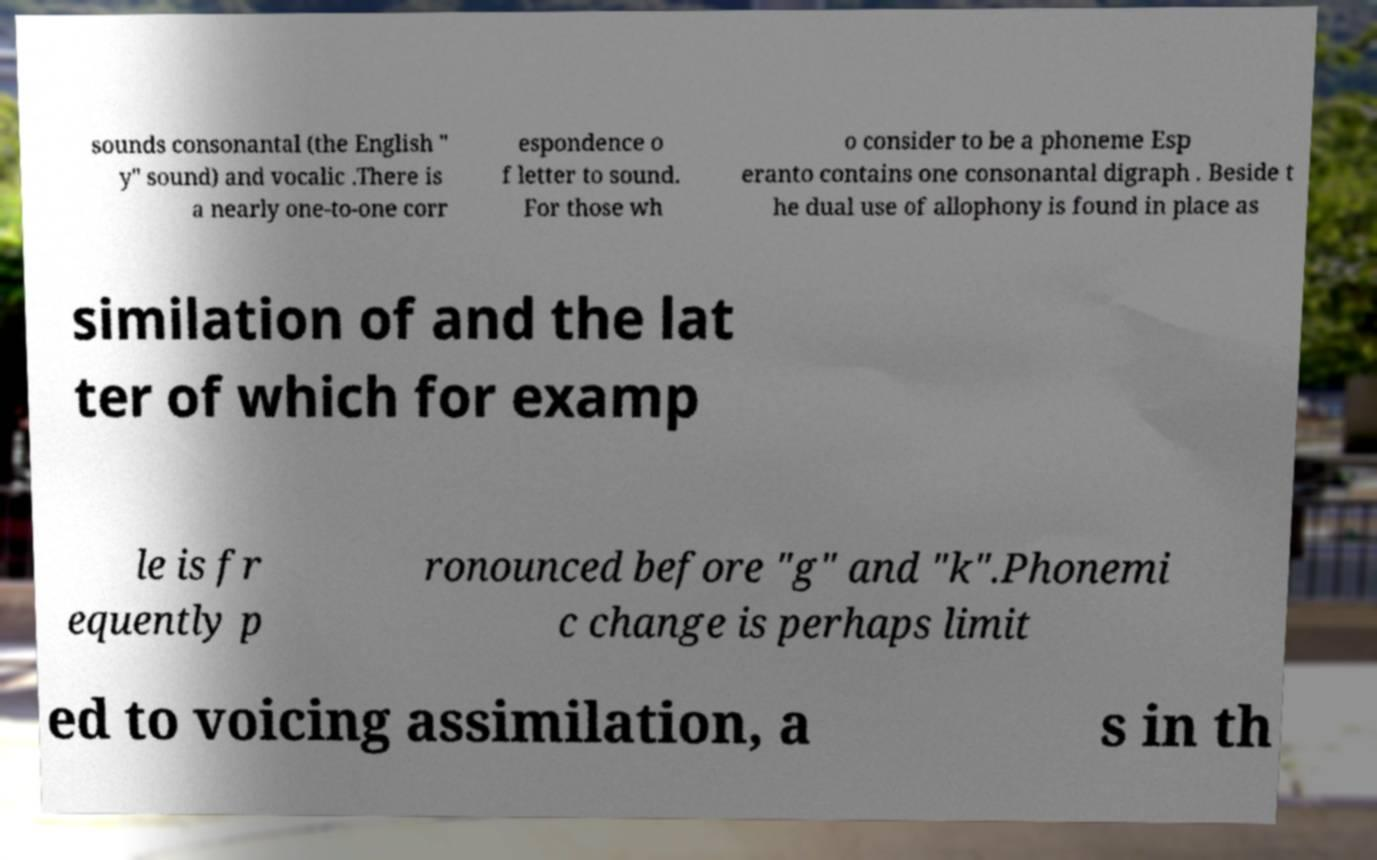Can you accurately transcribe the text from the provided image for me? sounds consonantal (the English " y" sound) and vocalic .There is a nearly one-to-one corr espondence o f letter to sound. For those wh o consider to be a phoneme Esp eranto contains one consonantal digraph . Beside t he dual use of allophony is found in place as similation of and the lat ter of which for examp le is fr equently p ronounced before "g" and "k".Phonemi c change is perhaps limit ed to voicing assimilation, a s in th 